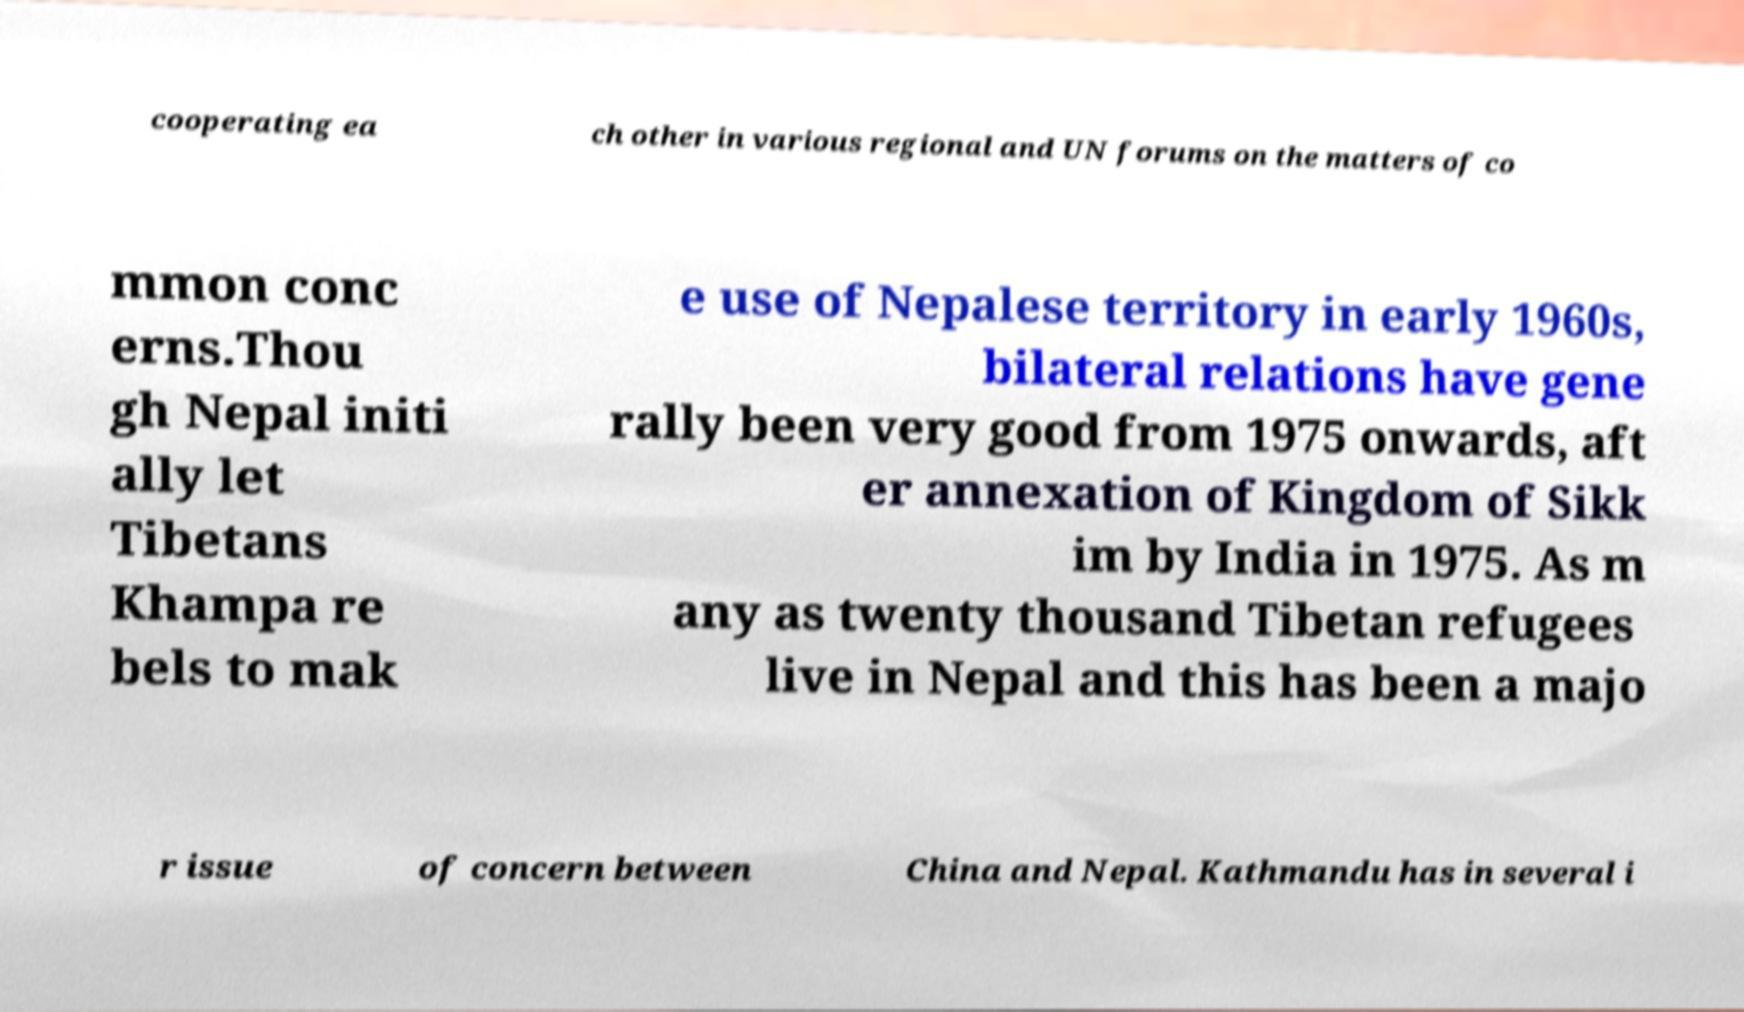There's text embedded in this image that I need extracted. Can you transcribe it verbatim? cooperating ea ch other in various regional and UN forums on the matters of co mmon conc erns.Thou gh Nepal initi ally let Tibetans Khampa re bels to mak e use of Nepalese territory in early 1960s, bilateral relations have gene rally been very good from 1975 onwards, aft er annexation of Kingdom of Sikk im by India in 1975. As m any as twenty thousand Tibetan refugees live in Nepal and this has been a majo r issue of concern between China and Nepal. Kathmandu has in several i 